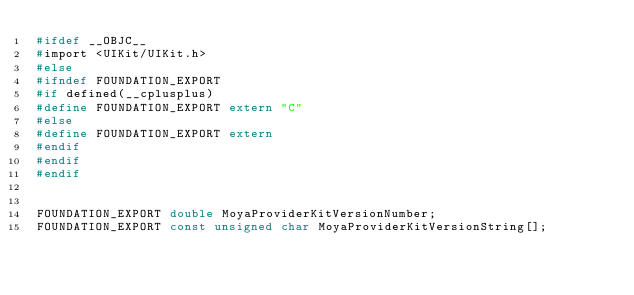<code> <loc_0><loc_0><loc_500><loc_500><_C_>#ifdef __OBJC__
#import <UIKit/UIKit.h>
#else
#ifndef FOUNDATION_EXPORT
#if defined(__cplusplus)
#define FOUNDATION_EXPORT extern "C"
#else
#define FOUNDATION_EXPORT extern
#endif
#endif
#endif


FOUNDATION_EXPORT double MoyaProviderKitVersionNumber;
FOUNDATION_EXPORT const unsigned char MoyaProviderKitVersionString[];

</code> 